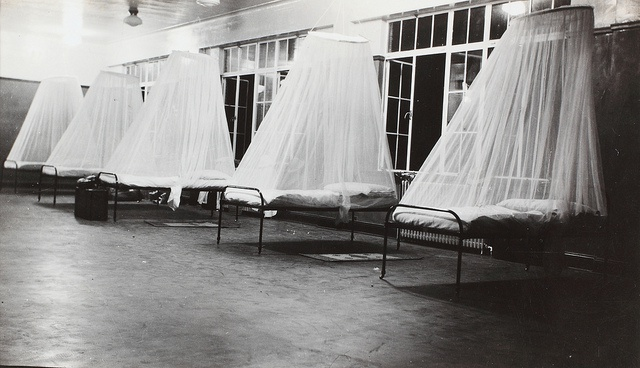Describe the objects in this image and their specific colors. I can see bed in lightgray, darkgray, gray, and black tones, bed in lightgray, black, darkgray, and gray tones, bed in lightgray, darkgray, black, and gray tones, bed in lightgray, darkgray, and gray tones, and bed in lightgray, darkgray, gray, and black tones in this image. 